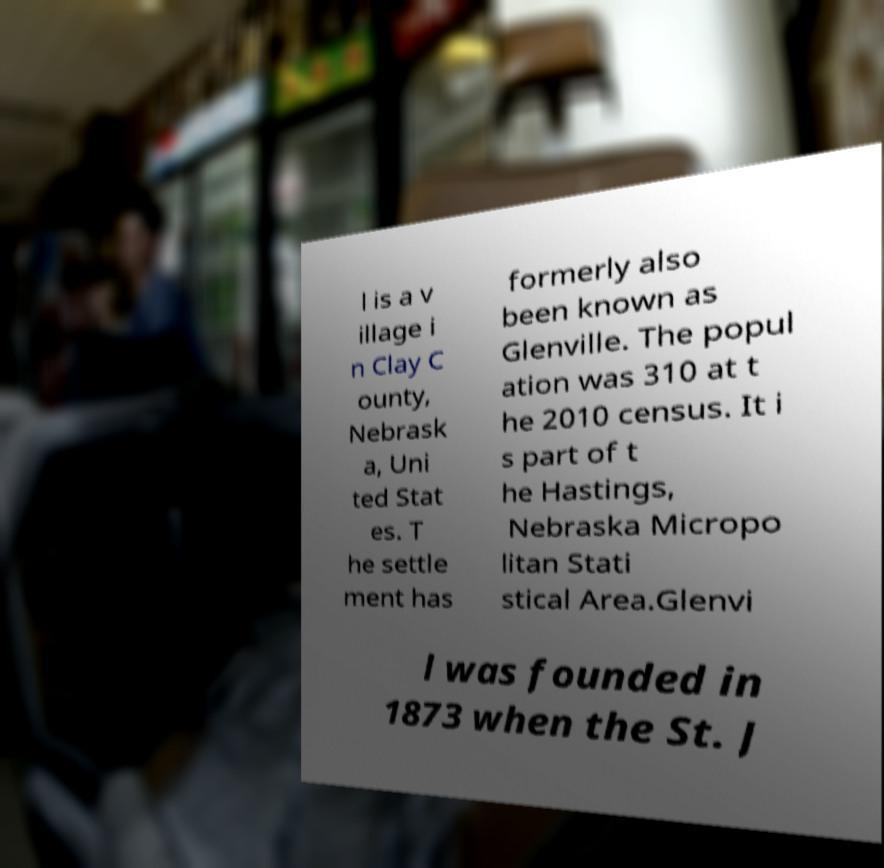Can you accurately transcribe the text from the provided image for me? l is a v illage i n Clay C ounty, Nebrask a, Uni ted Stat es. T he settle ment has formerly also been known as Glenville. The popul ation was 310 at t he 2010 census. It i s part of t he Hastings, Nebraska Micropo litan Stati stical Area.Glenvi l was founded in 1873 when the St. J 